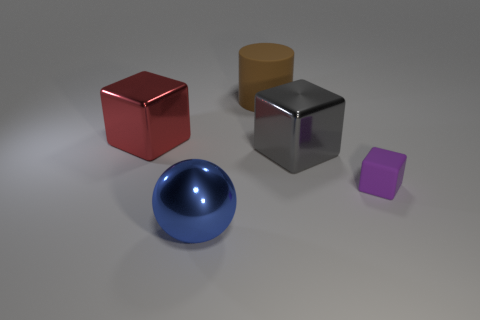Add 3 big yellow rubber things. How many objects exist? 8 Subtract all balls. How many objects are left? 4 Add 4 tiny purple rubber blocks. How many tiny purple rubber blocks exist? 5 Subtract 0 green cubes. How many objects are left? 5 Subtract all small objects. Subtract all gray metal cubes. How many objects are left? 3 Add 2 small matte objects. How many small matte objects are left? 3 